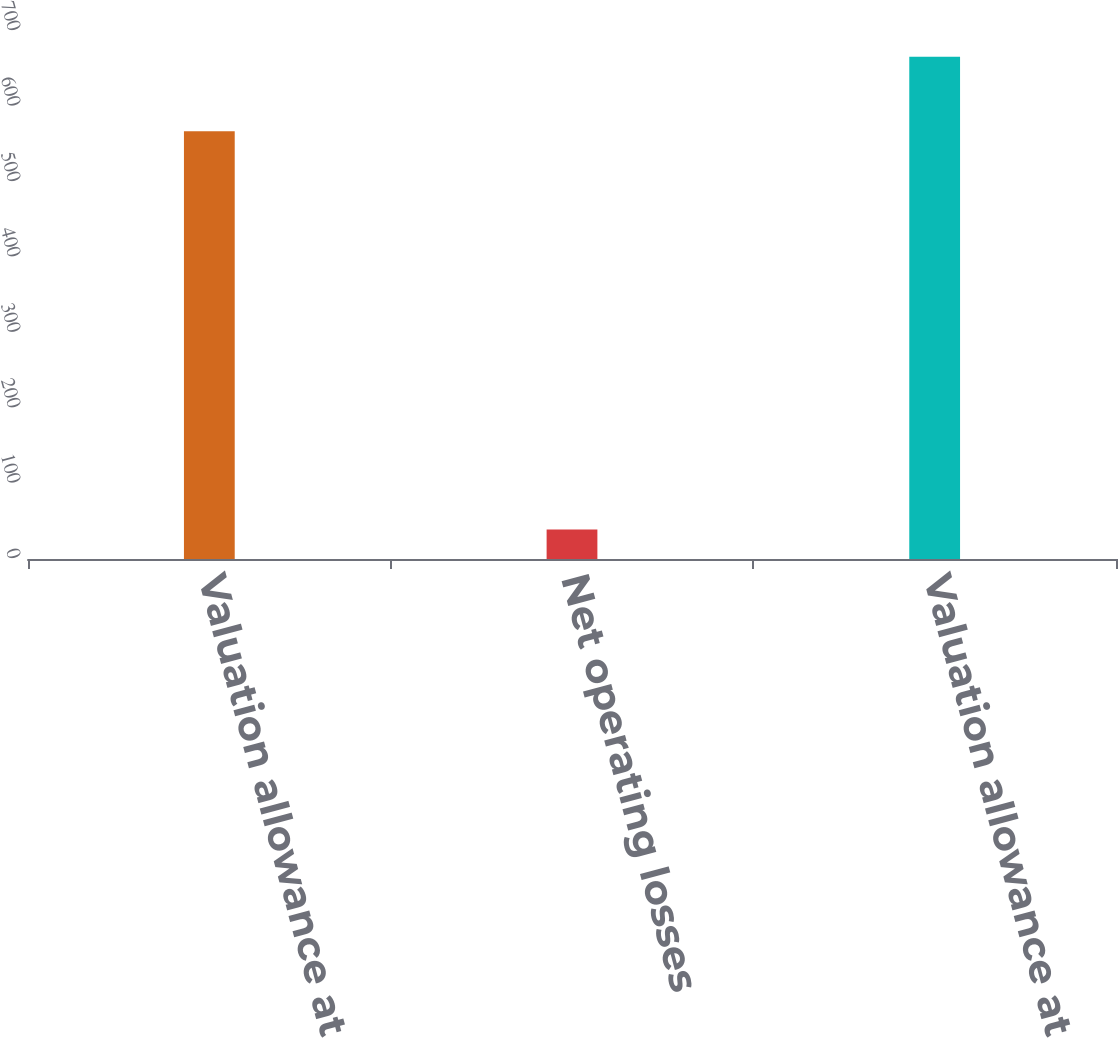Convert chart to OTSL. <chart><loc_0><loc_0><loc_500><loc_500><bar_chart><fcel>Valuation allowance at<fcel>Net operating losses<fcel>Valuation allowance at end of<nl><fcel>567<fcel>39<fcel>666<nl></chart> 